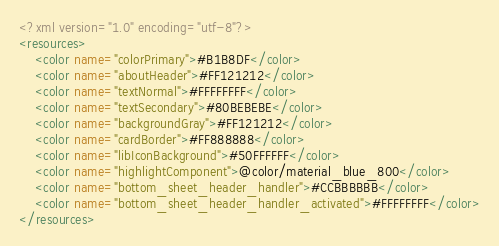<code> <loc_0><loc_0><loc_500><loc_500><_XML_><?xml version="1.0" encoding="utf-8"?>
<resources>
    <color name="colorPrimary">#B1B8DF</color>
    <color name="aboutHeader">#FF121212</color>
    <color name="textNormal">#FFFFFFFF</color>
    <color name="textSecondary">#80BEBEBE</color>
    <color name="backgroundGray">#FF121212</color>
    <color name="cardBorder">#FF888888</color>
    <color name="libIconBackground">#50FFFFFF</color>
    <color name="highlightComponent">@color/material_blue_800</color>
    <color name="bottom_sheet_header_handler">#CCBBBBBB</color>
    <color name="bottom_sheet_header_handler_activated">#FFFFFFFF</color>
</resources>
</code> 